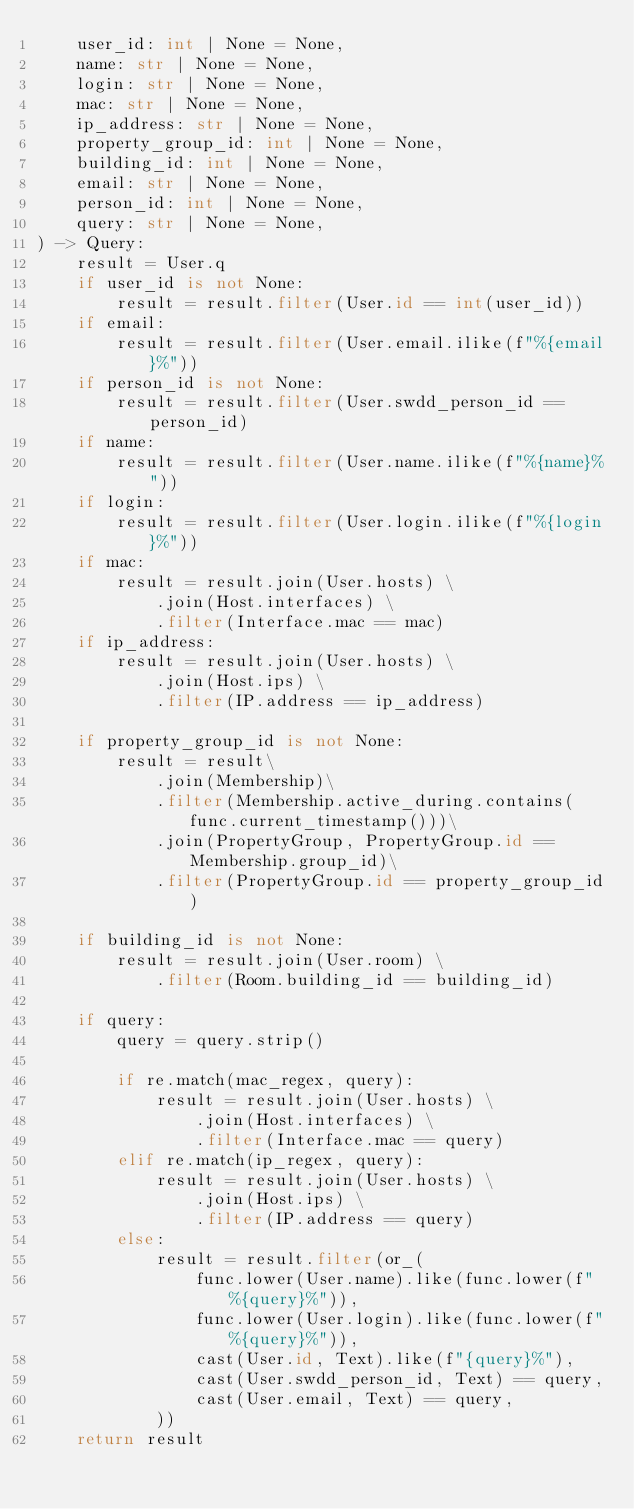<code> <loc_0><loc_0><loc_500><loc_500><_Python_>    user_id: int | None = None,
    name: str | None = None,
    login: str | None = None,
    mac: str | None = None,
    ip_address: str | None = None,
    property_group_id: int | None = None,
    building_id: int | None = None,
    email: str | None = None,
    person_id: int | None = None,
    query: str | None = None,
) -> Query:
    result = User.q
    if user_id is not None:
        result = result.filter(User.id == int(user_id))
    if email:
        result = result.filter(User.email.ilike(f"%{email}%"))
    if person_id is not None:
        result = result.filter(User.swdd_person_id == person_id)
    if name:
        result = result.filter(User.name.ilike(f"%{name}%"))
    if login:
        result = result.filter(User.login.ilike(f"%{login}%"))
    if mac:
        result = result.join(User.hosts) \
            .join(Host.interfaces) \
            .filter(Interface.mac == mac)
    if ip_address:
        result = result.join(User.hosts) \
            .join(Host.ips) \
            .filter(IP.address == ip_address)

    if property_group_id is not None:
        result = result\
            .join(Membership)\
            .filter(Membership.active_during.contains(func.current_timestamp()))\
            .join(PropertyGroup, PropertyGroup.id == Membership.group_id)\
            .filter(PropertyGroup.id == property_group_id)

    if building_id is not None:
        result = result.join(User.room) \
            .filter(Room.building_id == building_id)

    if query:
        query = query.strip()

        if re.match(mac_regex, query):
            result = result.join(User.hosts) \
                .join(Host.interfaces) \
                .filter(Interface.mac == query)
        elif re.match(ip_regex, query):
            result = result.join(User.hosts) \
                .join(Host.ips) \
                .filter(IP.address == query)
        else:
            result = result.filter(or_(
                func.lower(User.name).like(func.lower(f"%{query}%")),
                func.lower(User.login).like(func.lower(f"%{query}%")),
                cast(User.id, Text).like(f"{query}%"),
                cast(User.swdd_person_id, Text) == query,
                cast(User.email, Text) == query,
            ))
    return result
</code> 